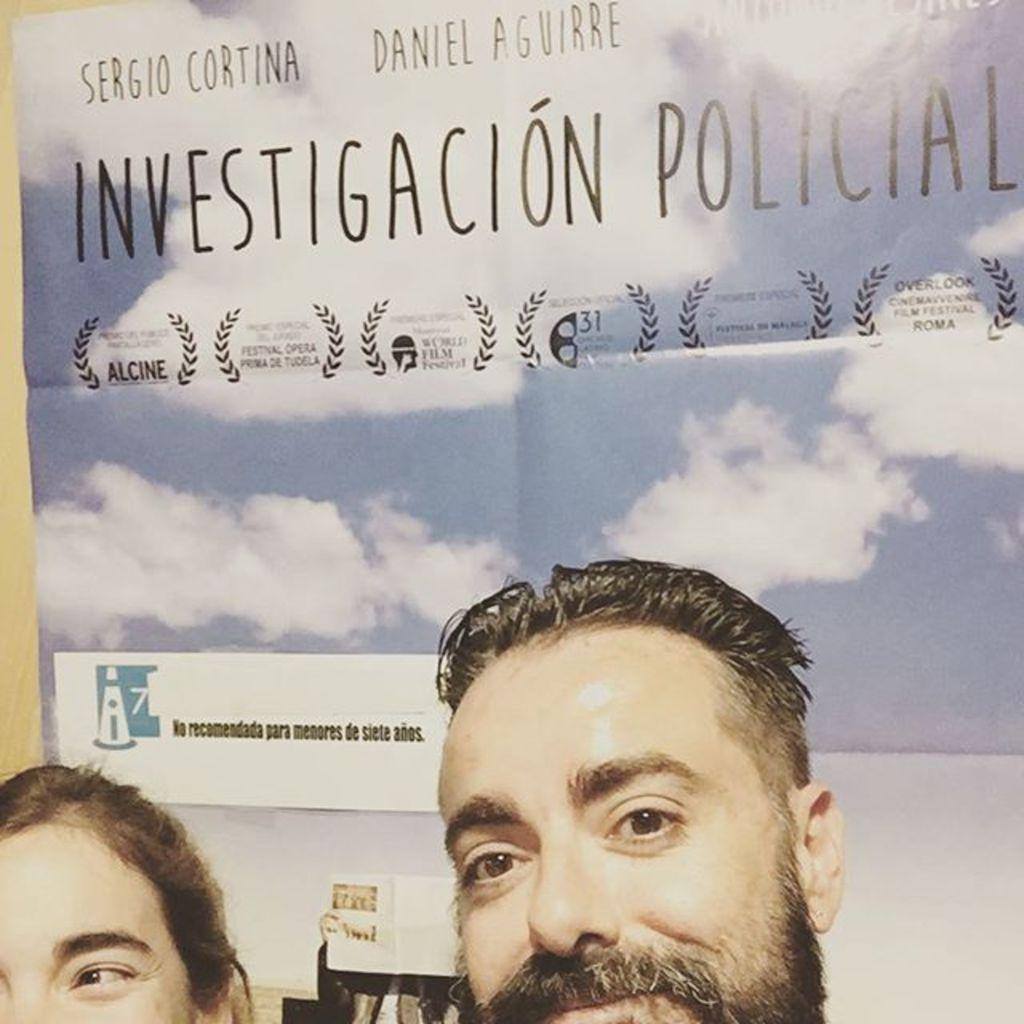How many people are present in the image? There is a man and a woman in the image. What type of image is it? The image appears to be a banner. Where is the banner located? The banner is attached to a wall. What type of baby is depicted on the banner? There is no baby depicted on the banner; it features a man and a woman. What belief is being promoted on the banner? The banner does not promote any specific belief; it simply shows a man and a woman. 